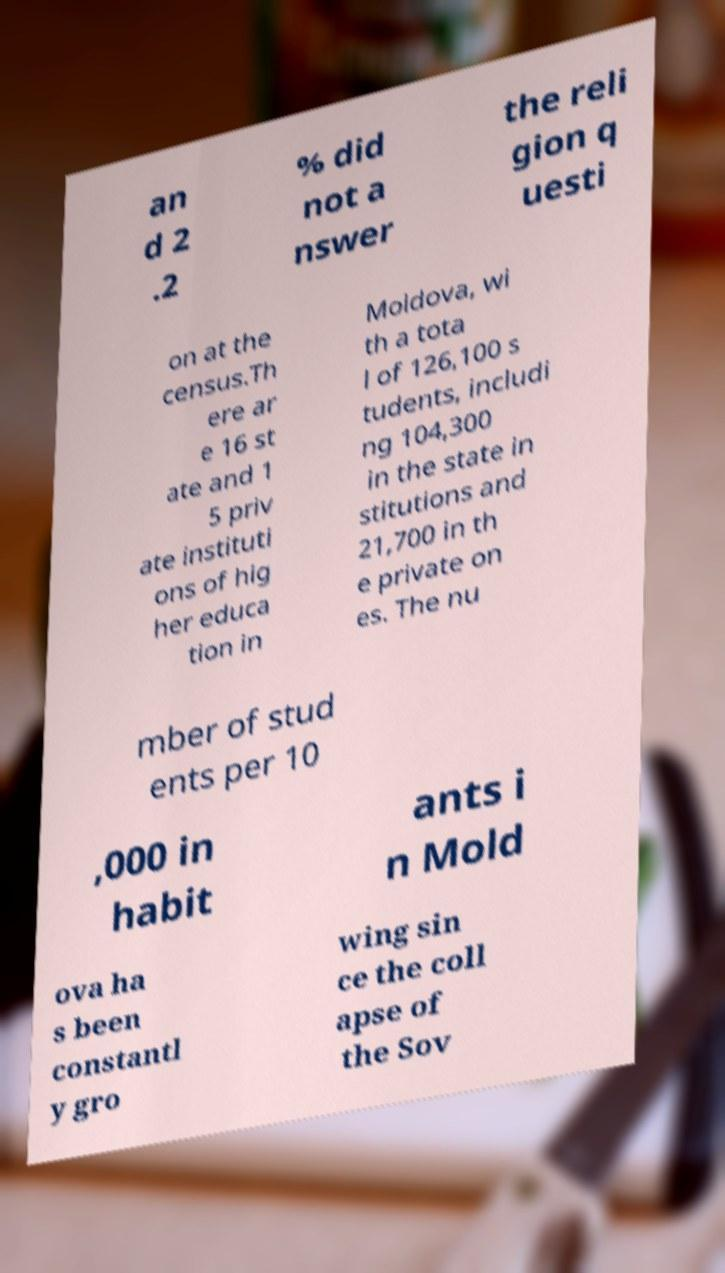For documentation purposes, I need the text within this image transcribed. Could you provide that? an d 2 .2 % did not a nswer the reli gion q uesti on at the census.Th ere ar e 16 st ate and 1 5 priv ate instituti ons of hig her educa tion in Moldova, wi th a tota l of 126,100 s tudents, includi ng 104,300 in the state in stitutions and 21,700 in th e private on es. The nu mber of stud ents per 10 ,000 in habit ants i n Mold ova ha s been constantl y gro wing sin ce the coll apse of the Sov 